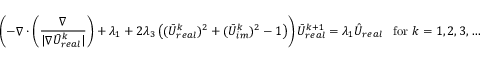Convert formula to latex. <formula><loc_0><loc_0><loc_500><loc_500>\left ( - \nabla \cdot \left ( \frac { \nabla } { | \nabla \bar { U } _ { r e a l } ^ { k } | } \right ) + \lambda _ { 1 } + 2 \lambda _ { 3 } \left ( ( \bar { U } _ { r e a l } ^ { k } ) ^ { 2 } + ( \bar { U } _ { i m } ^ { k } ) ^ { 2 } - 1 \right ) \right ) \bar { U } _ { r e a l } ^ { k + 1 } = \lambda _ { 1 } \hat { U } _ { r e a l } \, f o r \, k = 1 , 2 , 3 , \dots</formula> 